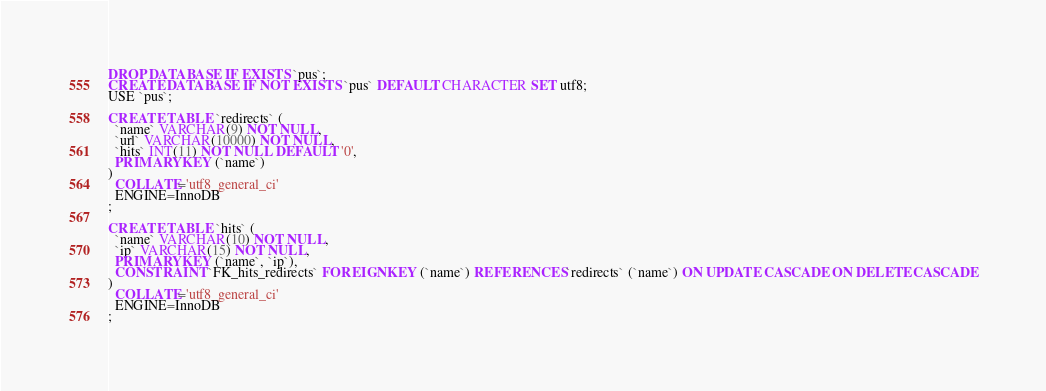<code> <loc_0><loc_0><loc_500><loc_500><_SQL_>DROP DATABASE IF EXISTS `pus`;
CREATE DATABASE IF NOT EXISTS `pus` DEFAULT CHARACTER SET utf8;
USE `pus`;

CREATE TABLE `redirects` (
  `name` VARCHAR(9) NOT NULL,
  `url` VARCHAR(10000) NOT NULL,
  `hits` INT(11) NOT NULL DEFAULT '0',
  PRIMARY KEY (`name`)
)
  COLLATE='utf8_general_ci'
  ENGINE=InnoDB
;

CREATE TABLE `hits` (
  `name` VARCHAR(10) NOT NULL,
  `ip` VARCHAR(15) NOT NULL,
  PRIMARY KEY (`name`, `ip`),
  CONSTRAINT `FK_hits_redirects` FOREIGN KEY (`name`) REFERENCES `redirects` (`name`) ON UPDATE CASCADE ON DELETE CASCADE
)
  COLLATE='utf8_general_ci'
  ENGINE=InnoDB
;
</code> 